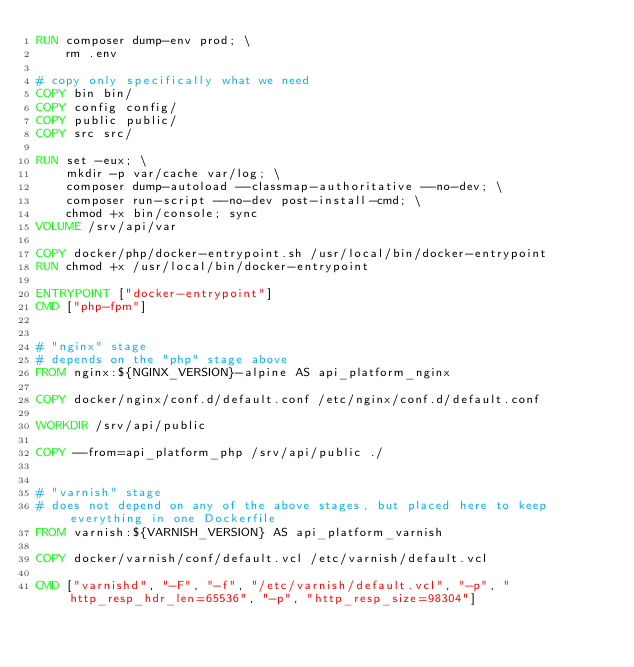<code> <loc_0><loc_0><loc_500><loc_500><_Dockerfile_>RUN composer dump-env prod; \
	rm .env

# copy only specifically what we need
COPY bin bin/
COPY config config/
COPY public public/
COPY src src/

RUN set -eux; \
	mkdir -p var/cache var/log; \
	composer dump-autoload --classmap-authoritative --no-dev; \
	composer run-script --no-dev post-install-cmd; \
	chmod +x bin/console; sync
VOLUME /srv/api/var

COPY docker/php/docker-entrypoint.sh /usr/local/bin/docker-entrypoint
RUN chmod +x /usr/local/bin/docker-entrypoint

ENTRYPOINT ["docker-entrypoint"]
CMD ["php-fpm"]


# "nginx" stage
# depends on the "php" stage above
FROM nginx:${NGINX_VERSION}-alpine AS api_platform_nginx

COPY docker/nginx/conf.d/default.conf /etc/nginx/conf.d/default.conf

WORKDIR /srv/api/public

COPY --from=api_platform_php /srv/api/public ./


# "varnish" stage
# does not depend on any of the above stages, but placed here to keep everything in one Dockerfile
FROM varnish:${VARNISH_VERSION} AS api_platform_varnish

COPY docker/varnish/conf/default.vcl /etc/varnish/default.vcl

CMD ["varnishd", "-F", "-f", "/etc/varnish/default.vcl", "-p", "http_resp_hdr_len=65536", "-p", "http_resp_size=98304"]
</code> 